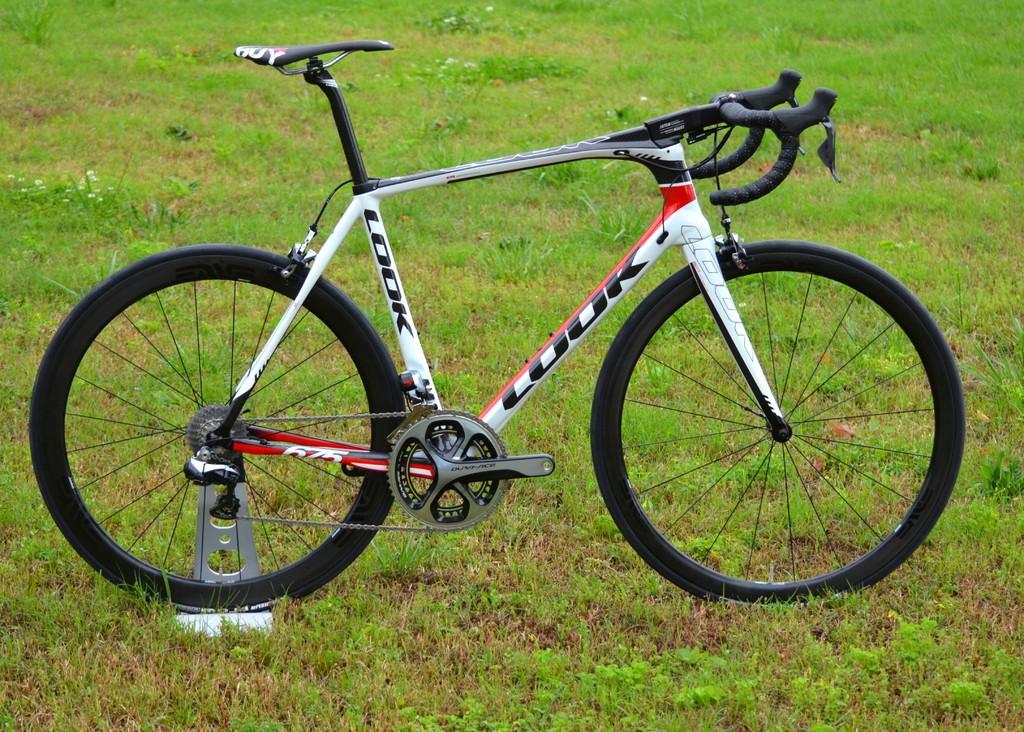Describe this image in one or two sentences. In the picture we can see a bicycle, which is white in color with black wheels, handle and seat and it is placed on the grass surface. 